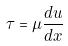Convert formula to latex. <formula><loc_0><loc_0><loc_500><loc_500>\tau = \mu \frac { d u } { d x }</formula> 